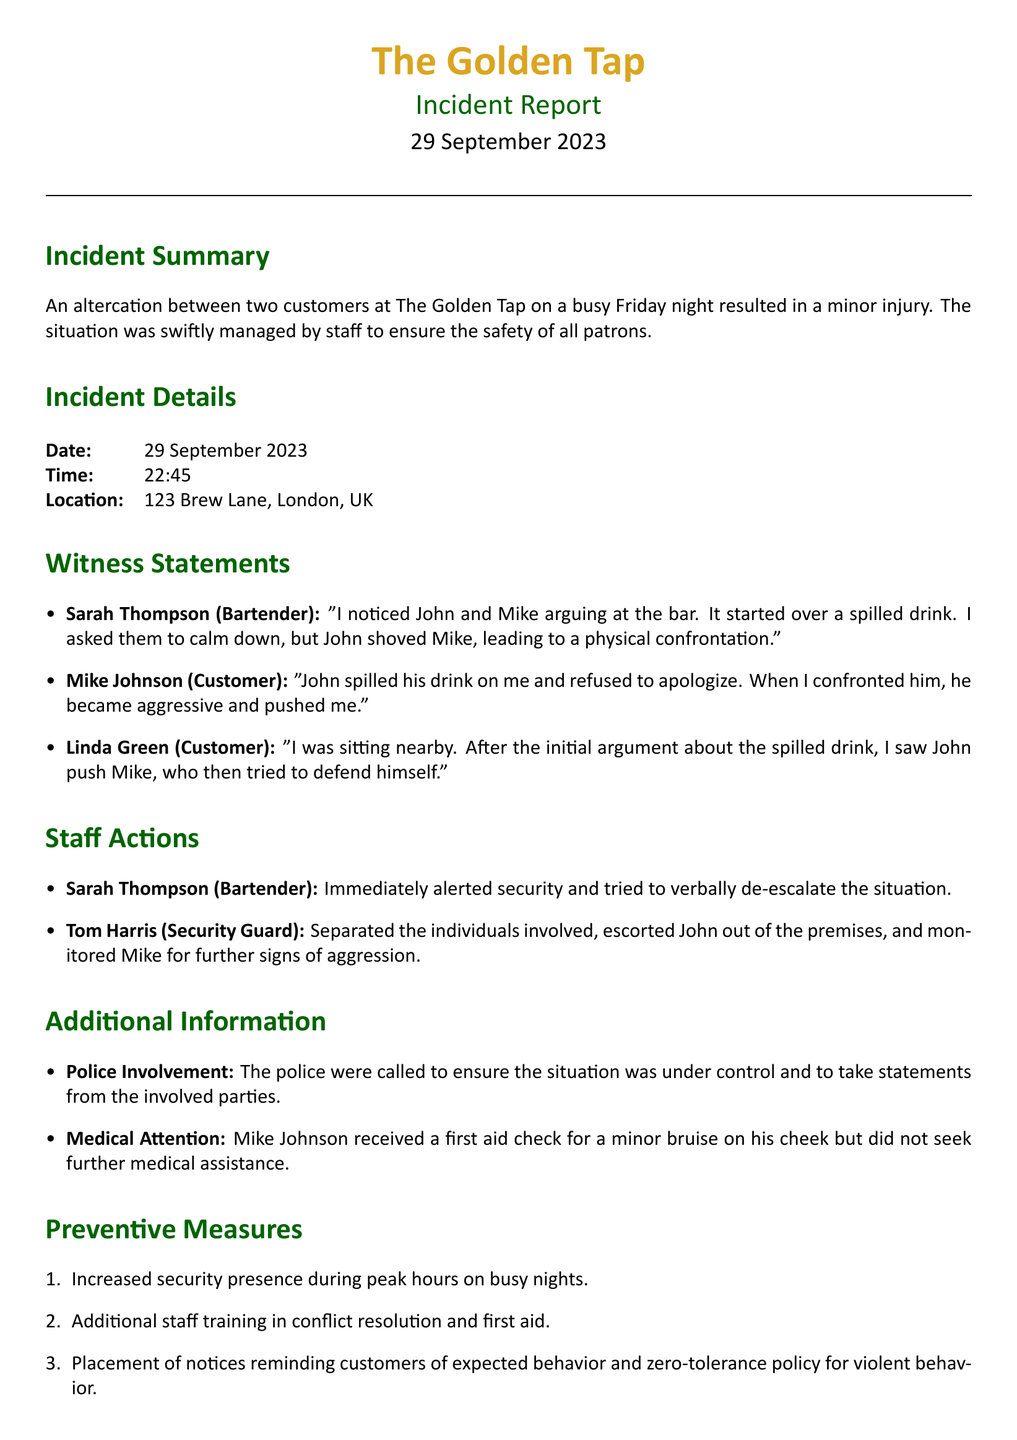What is the date of the incident? The date of the incident is explicitly stated in the document.
Answer: 29 September 2023 What time did the altercation occur? The document mentions the time of the incident in the incident details section.
Answer: 22:45 Who was the security guard involved? The name of the security guard is mentioned in the staff actions section.
Answer: Tom Harris What was the cause of the argument? The document describes the initial conflict between the customers.
Answer: Spilled drink What injury did Mike Johnson sustain? The document details the nature of the injury reported by Mike Johnson.
Answer: Bruise on his cheek What actions did Sarah Thompson take during the incident? The document specifies Sarah Thompson's response to the situation.
Answer: Alerted security What measures will be implemented to prevent future incidents? The document lists several preventive measures to enhance safety.
Answer: Increased security presence How did the staff try to manage the situation? The document outlines the staff's approach to handling the altercation.
Answer: Verbal de-escalation Was police involvement necessary? The document states whether police were called to the scene.
Answer: Yes 